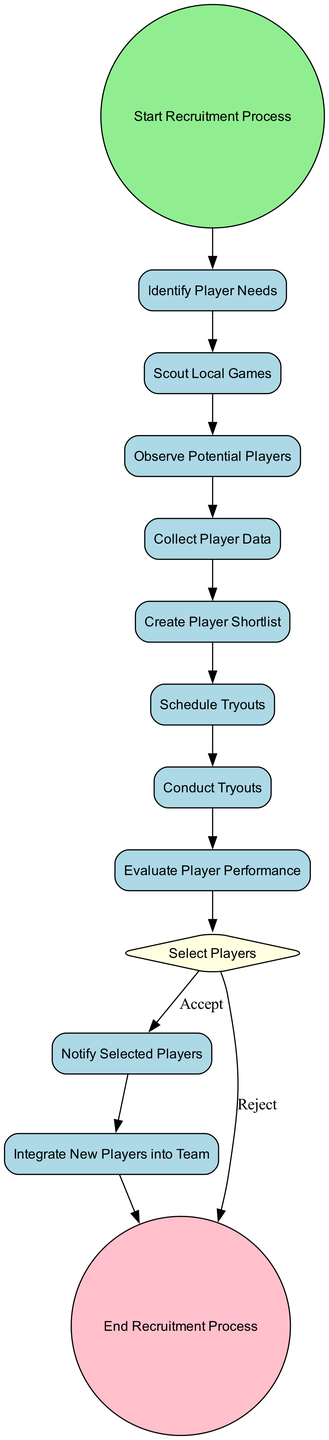What is the first activity in the recruitment process? The diagram indicates that the first activity is directly linked to the "Start Recruitment Process" event, which leads to "Identify Player Needs".
Answer: Identify Player Needs How many activities are there in the recruitment process? By counting the activities represented in the diagram excluding start and end events, we find there are 8 activities present from "Identify Player Needs" through "Conduct Tryouts".
Answer: 8 What decision point is present in the recruitment process? The diagram depicts a decision point labeled “Select Players,” indicating a branching process where players may either be accepted or rejected.
Answer: Select Players Which activity comes after "Conduct Tryouts"? Following "Conduct Tryouts", the next activity as per the flow of the diagram is "Evaluate Player Performance".
Answer: Evaluate Player Performance If a player is rejected, what happens next in the process? The diagram shows that if a player is "Rejected", the process ends without further activities related to that player, as indicated by the edge leading to "End Recruitment Process".
Answer: End Recruitment Process What is the last activity in the recruitment process? The final point in the diagram, following all activities, is labeled as "End Recruitment Process", marking the conclusion of the recruitment process.
Answer: End Recruitment Process Which activity involves interaction with potential players? "Conduct Tryouts" is the activity that involves direct interaction with potential players through assessment during the recruitment process.
Answer: Conduct Tryouts What activity follows creating the player shortlist? The subsequent activity after "Create Player Shortlist" is "Schedule Tryouts," which is the next logical step in the recruitment process.
Answer: Schedule Tryouts 